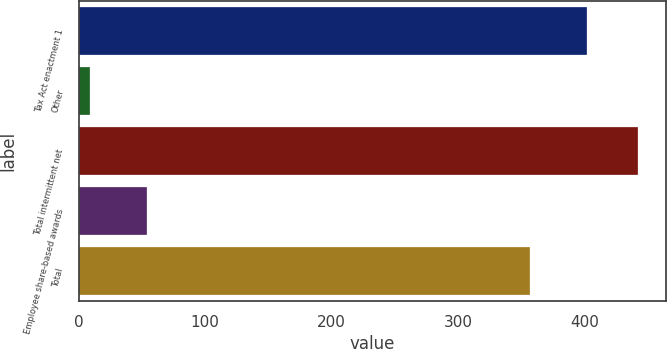Convert chart. <chart><loc_0><loc_0><loc_500><loc_500><bar_chart><fcel>Tax Act enactment 1<fcel>Other<fcel>Total intermittent net<fcel>Employee share-based awards<fcel>Total<nl><fcel>402<fcel>9<fcel>442.2<fcel>54<fcel>357<nl></chart> 